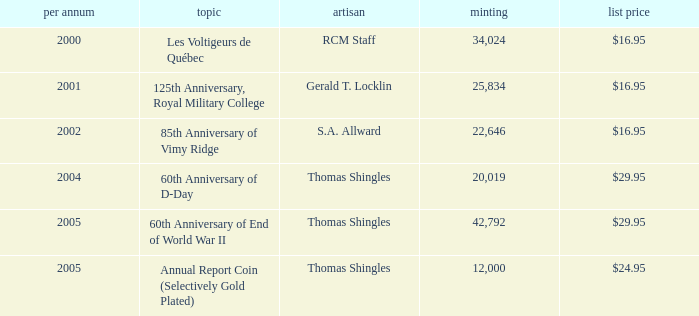Would you be able to parse every entry in this table? {'header': ['per annum', 'topic', 'artisan', 'minting', 'list price'], 'rows': [['2000', 'Les Voltigeurs de Québec', 'RCM Staff', '34,024', '$16.95'], ['2001', '125th Anniversary, Royal Military College', 'Gerald T. Locklin', '25,834', '$16.95'], ['2002', '85th Anniversary of Vimy Ridge', 'S.A. Allward', '22,646', '$16.95'], ['2004', '60th Anniversary of D-Day', 'Thomas Shingles', '20,019', '$29.95'], ['2005', '60th Anniversary of End of World War II', 'Thomas Shingles', '42,792', '$29.95'], ['2005', 'Annual Report Coin (Selectively Gold Plated)', 'Thomas Shingles', '12,000', '$24.95']]} What year was S.A. Allward's theme that had an issue price of $16.95 released? 2002.0. 